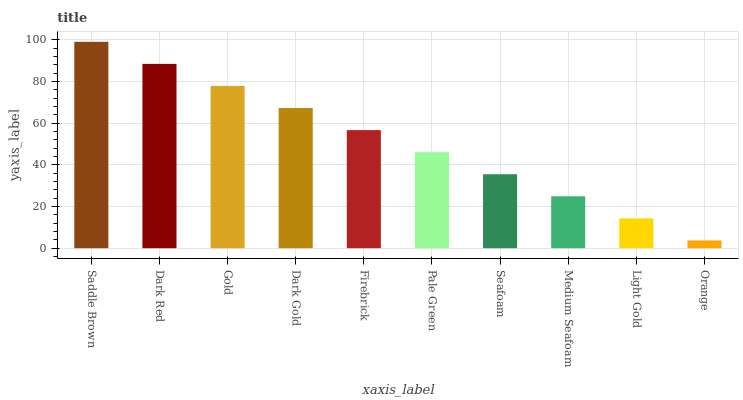Is Orange the minimum?
Answer yes or no. Yes. Is Saddle Brown the maximum?
Answer yes or no. Yes. Is Dark Red the minimum?
Answer yes or no. No. Is Dark Red the maximum?
Answer yes or no. No. Is Saddle Brown greater than Dark Red?
Answer yes or no. Yes. Is Dark Red less than Saddle Brown?
Answer yes or no. Yes. Is Dark Red greater than Saddle Brown?
Answer yes or no. No. Is Saddle Brown less than Dark Red?
Answer yes or no. No. Is Firebrick the high median?
Answer yes or no. Yes. Is Pale Green the low median?
Answer yes or no. Yes. Is Pale Green the high median?
Answer yes or no. No. Is Dark Gold the low median?
Answer yes or no. No. 